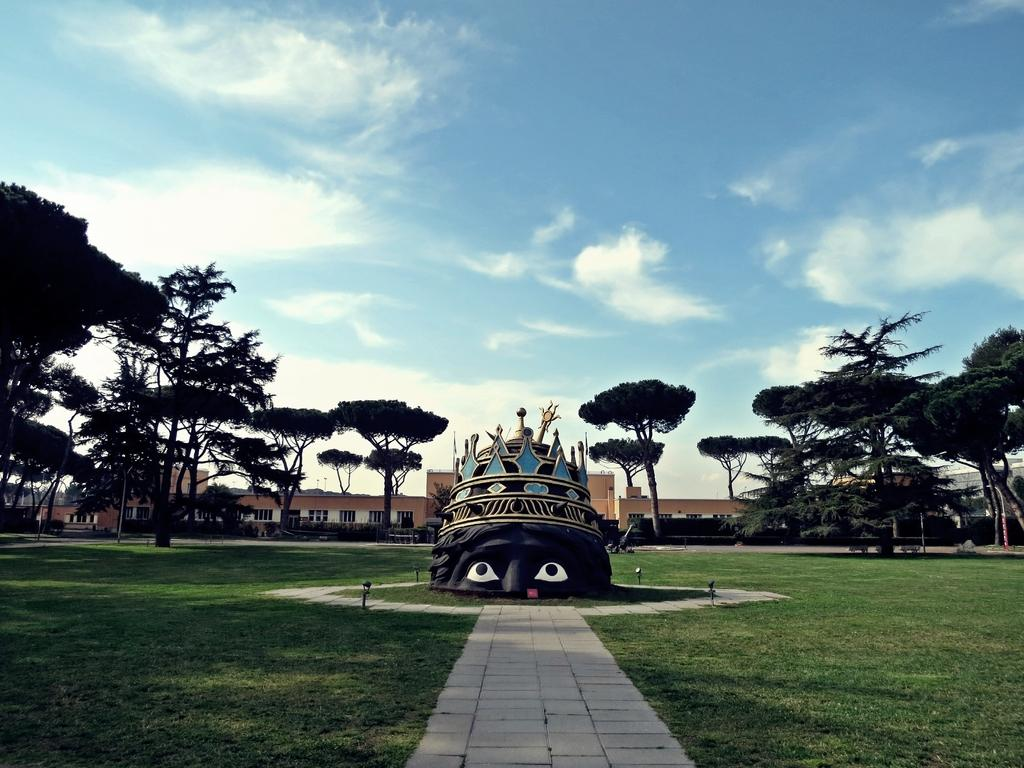What is the main subject in the center of the image? There is a structure in the center of the image. What can be seen behind the structure? There are trees and buildings behind the structure. What is visible in the sky at the top of the image? Clouds are visible in the sky at the top of the image. What is the title of the book that is being read by the person in the image? There is no person or book present in the image; it only features a structure, trees, buildings, and clouds. 